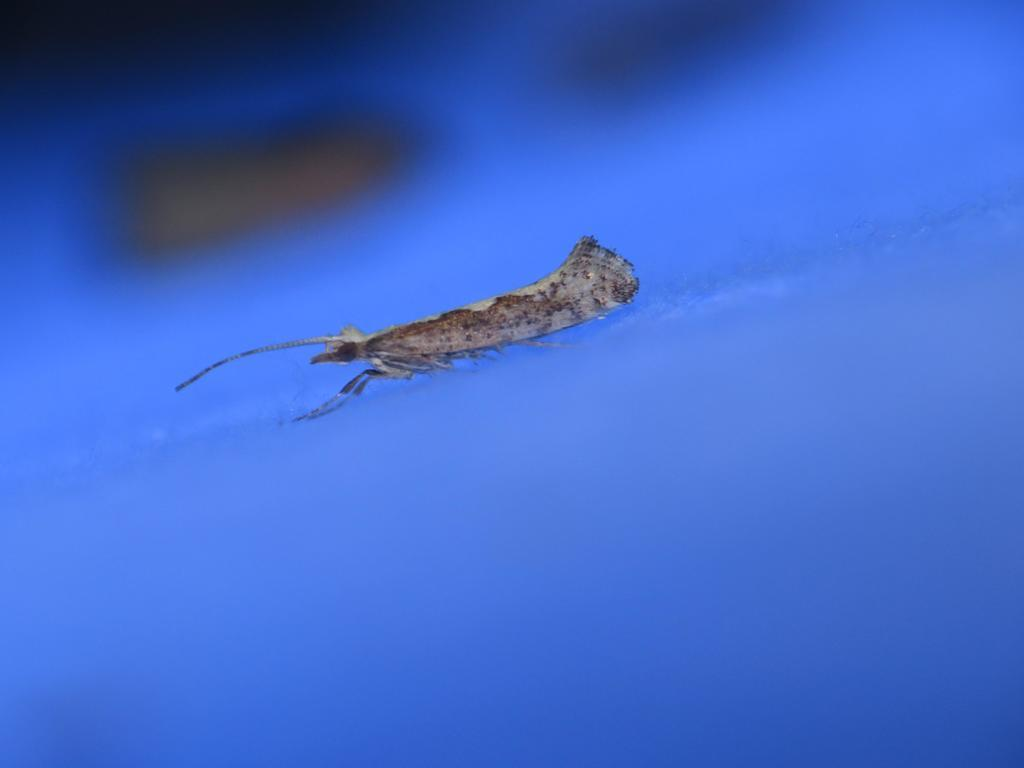What is located in the foreground of the image? There is an insect in the foreground of the image. Can you describe the blue object at the bottom of the image? There is a blue object at the bottom of the image. How many dogs are interacting with the snail in the image? There are no dogs or snails present in the image. 